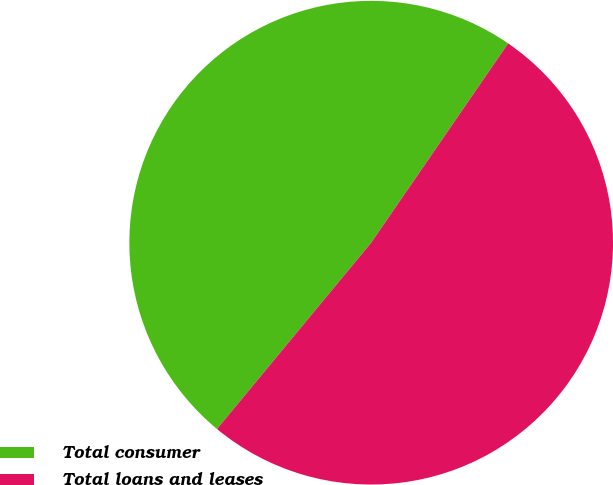Convert chart to OTSL. <chart><loc_0><loc_0><loc_500><loc_500><pie_chart><fcel>Total consumer<fcel>Total loans and leases<nl><fcel>48.58%<fcel>51.42%<nl></chart> 